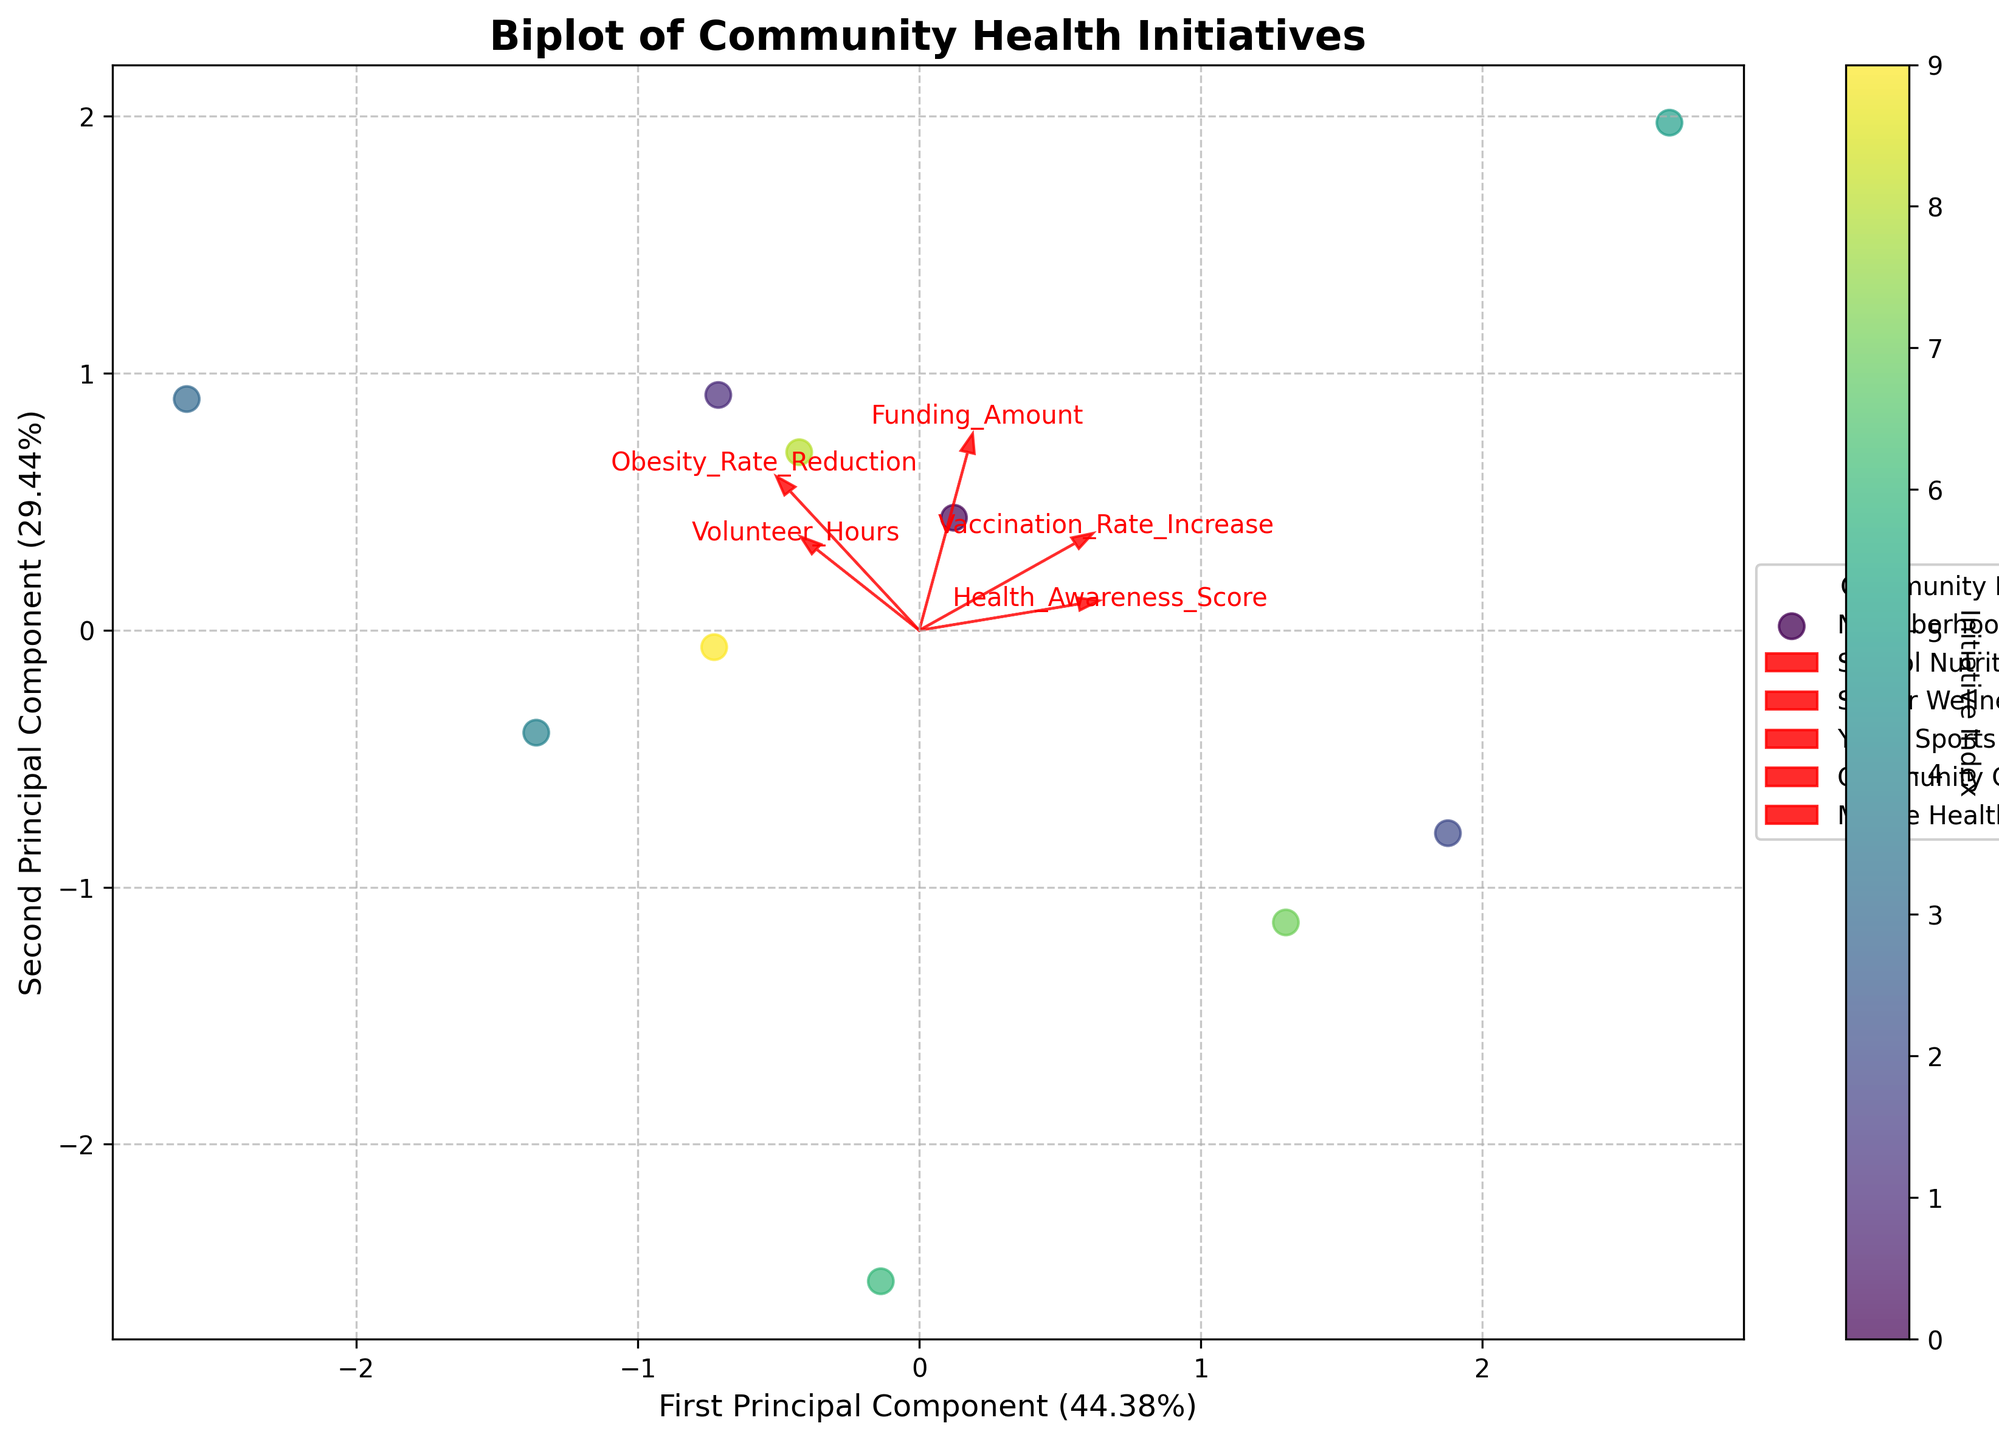How many community initiatives are plotted on the biplot? The biplot shows different community initiatives as discrete data points. By examining the legend or the data points on the plot, one can count that there are ten unique initiatives.
Answer: Ten What do the arrows represent on the biplot? The arrows represent the original variables (features) in the PCA-transformed space. Each arrow shows the direction and magnitude of each variable's contribution to the principal components.
Answer: Original variables Which principal component explains more of the variance in the data? The x-axis is labeled as the first principal component, and the y-axis is labeled as the second principal component. By checking their labels, we see the first principal component explains more variance, as noted by its higher percentage (e.g., 60%) compared to the second (e.g., 25%).
Answer: First principal component Which feature has the largest contribution to the first principal component? To determine this, look at the length of the arrows on the plot. The feature with the arrow extending furthest along the x-axis contributes most to the first principal component.
Answer: Funding Amount / Health Awareness Score (depending on visualization) Is there a community initiative that stands out as an outlier in the plot? By scanning the plot for any data points that are notably far from others, we can identify if there's an outlier. A point that is far away from the cluster indicates it behaves differently than the majority.
Answer: (Identify specific initiative, e.g., Mobile Health Clinics if it's far from others) How are the features 'Obesity Rate Reduction' and 'Vaccination Rate Increase' oriented relative to each other on the biplot? Compare the direction of the arrows for these two features. If the arrows point in approximately the same direction, the features are positively correlated. If they point in opposite directions, the features are negatively correlated.
Answer: (Specify direction, e.g., positively correlated if they point similarly) Which two community initiatives are closest to each other on the biplot? By visually inspecting the distance between data points on the plot, we can identify which two initiatives are most closely clustered.
Answer: (Specify two initiatives, e.g., Family Exercise Initiatives and Neighborhood Health Fairs) Which feature appears to be most orthogonal (least correlated) to the 'Volunteer Hours' feature on the plot? Look for the feature whose arrow is most perpendicular to the 'Volunteer Hours' arrow. Orthogonal arrows imply no correlation.
Answer: (Specify feature, e.g., Obesity Rate Reduction) Is there a feature that contributes almost equally to both principal components? An arrow pointing at a roughly 45-degree angle to both axes suggests that the feature contributes almost equally to both principal components.
Answer: (Specify feature, e.g., Health Awareness Score) 